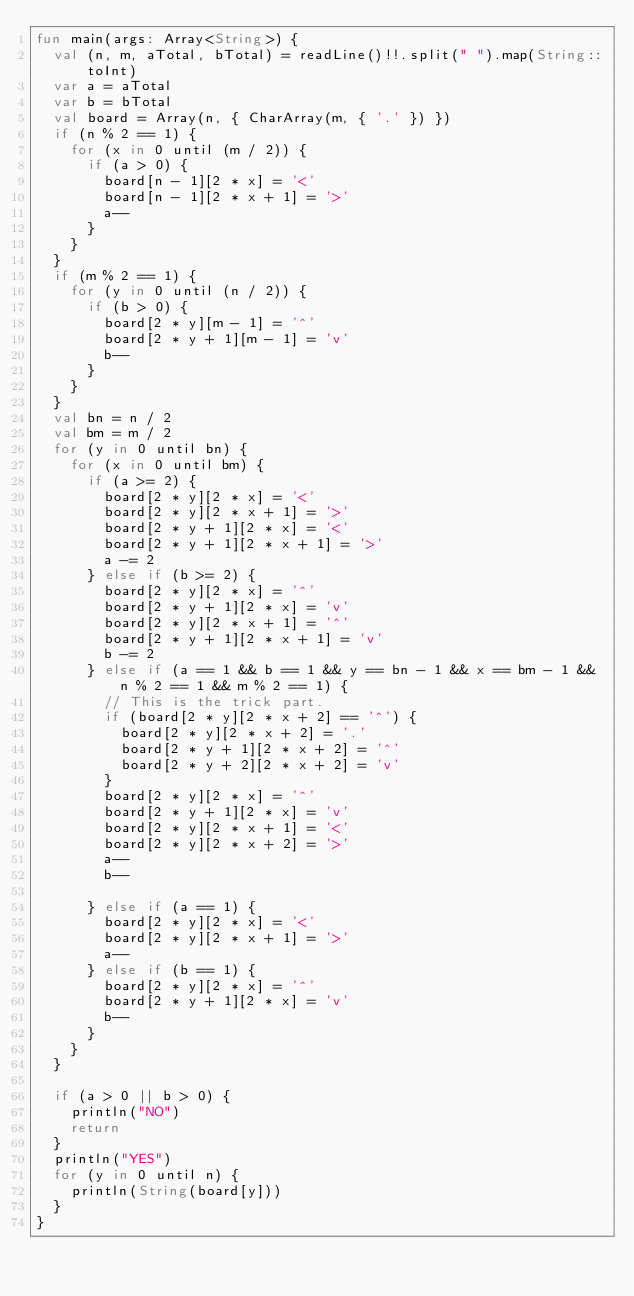Convert code to text. <code><loc_0><loc_0><loc_500><loc_500><_Kotlin_>fun main(args: Array<String>) {
  val (n, m, aTotal, bTotal) = readLine()!!.split(" ").map(String::toInt)
  var a = aTotal
  var b = bTotal
  val board = Array(n, { CharArray(m, { '.' }) })
  if (n % 2 == 1) {
    for (x in 0 until (m / 2)) {
      if (a > 0) {
        board[n - 1][2 * x] = '<'
        board[n - 1][2 * x + 1] = '>'
        a--
      }
    }
  }
  if (m % 2 == 1) {
    for (y in 0 until (n / 2)) {
      if (b > 0) {
        board[2 * y][m - 1] = '^'
        board[2 * y + 1][m - 1] = 'v'
        b--
      }
    }
  }
  val bn = n / 2
  val bm = m / 2
  for (y in 0 until bn) {
    for (x in 0 until bm) {
      if (a >= 2) {
        board[2 * y][2 * x] = '<'
        board[2 * y][2 * x + 1] = '>'
        board[2 * y + 1][2 * x] = '<'
        board[2 * y + 1][2 * x + 1] = '>'
        a -= 2
      } else if (b >= 2) {
        board[2 * y][2 * x] = '^'
        board[2 * y + 1][2 * x] = 'v'
        board[2 * y][2 * x + 1] = '^'
        board[2 * y + 1][2 * x + 1] = 'v'
        b -= 2
      } else if (a == 1 && b == 1 && y == bn - 1 && x == bm - 1 && n % 2 == 1 && m % 2 == 1) {
        // This is the trick part.
        if (board[2 * y][2 * x + 2] == '^') {
          board[2 * y][2 * x + 2] = '.'
          board[2 * y + 1][2 * x + 2] = '^'
          board[2 * y + 2][2 * x + 2] = 'v'
        }
        board[2 * y][2 * x] = '^'
        board[2 * y + 1][2 * x] = 'v'
        board[2 * y][2 * x + 1] = '<'
        board[2 * y][2 * x + 2] = '>'
        a--
        b--

      } else if (a == 1) {
        board[2 * y][2 * x] = '<'
        board[2 * y][2 * x + 1] = '>'
        a--
      } else if (b == 1) {
        board[2 * y][2 * x] = '^'
        board[2 * y + 1][2 * x] = 'v'
        b--
      }
    }
  }

  if (a > 0 || b > 0) {
    println("NO")
    return
  }
  println("YES")
  for (y in 0 until n) {
    println(String(board[y]))
  }
}</code> 